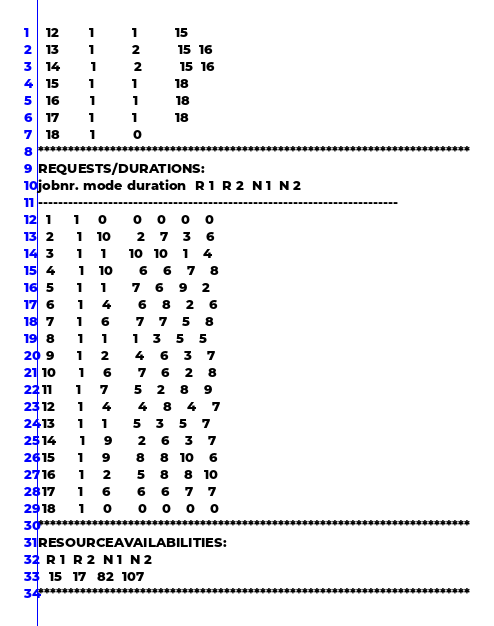<code> <loc_0><loc_0><loc_500><loc_500><_ObjectiveC_>  12        1          1          15
  13        1          2          15  16
  14        1          2          15  16
  15        1          1          18
  16        1          1          18
  17        1          1          18
  18        1          0        
************************************************************************
REQUESTS/DURATIONS:
jobnr. mode duration  R 1  R 2  N 1  N 2
------------------------------------------------------------------------
  1      1     0       0    0    0    0
  2      1    10       2    7    3    6
  3      1     1      10   10    1    4
  4      1    10       6    6    7    8
  5      1     1       7    6    9    2
  6      1     4       6    8    2    6
  7      1     6       7    7    5    8
  8      1     1       1    3    5    5
  9      1     2       4    6    3    7
 10      1     6       7    6    2    8
 11      1     7       5    2    8    9
 12      1     4       4    8    4    7
 13      1     1       5    3    5    7
 14      1     9       2    6    3    7
 15      1     9       8    8   10    6
 16      1     2       5    8    8   10
 17      1     6       6    6    7    7
 18      1     0       0    0    0    0
************************************************************************
RESOURCEAVAILABILITIES:
  R 1  R 2  N 1  N 2
   15   17   82  107
************************************************************************
</code> 